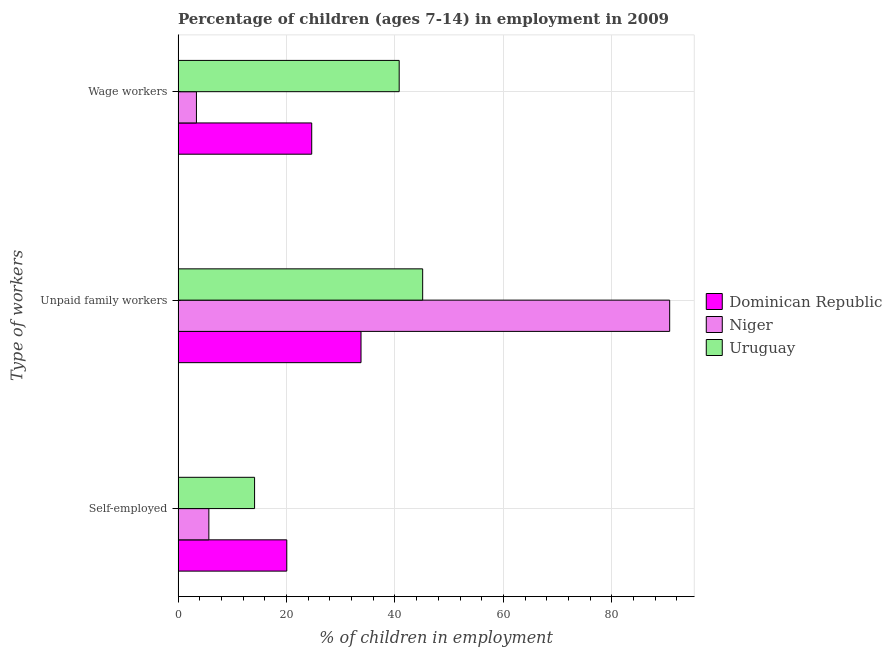How many different coloured bars are there?
Give a very brief answer. 3. How many groups of bars are there?
Provide a short and direct response. 3. What is the label of the 3rd group of bars from the top?
Provide a short and direct response. Self-employed. What is the percentage of self employed children in Niger?
Ensure brevity in your answer.  5.68. Across all countries, what is the maximum percentage of children employed as wage workers?
Ensure brevity in your answer.  40.78. Across all countries, what is the minimum percentage of children employed as unpaid family workers?
Ensure brevity in your answer.  33.74. In which country was the percentage of children employed as unpaid family workers maximum?
Your response must be concise. Niger. In which country was the percentage of children employed as unpaid family workers minimum?
Keep it short and to the point. Dominican Republic. What is the total percentage of children employed as wage workers in the graph?
Ensure brevity in your answer.  68.82. What is the difference between the percentage of self employed children in Dominican Republic and that in Niger?
Provide a succinct answer. 14.37. What is the difference between the percentage of children employed as unpaid family workers in Dominican Republic and the percentage of self employed children in Niger?
Ensure brevity in your answer.  28.06. What is the average percentage of children employed as unpaid family workers per country?
Offer a terse response. 56.5. What is the difference between the percentage of children employed as unpaid family workers and percentage of children employed as wage workers in Dominican Republic?
Your answer should be compact. 9.09. What is the ratio of the percentage of self employed children in Dominican Republic to that in Niger?
Offer a very short reply. 3.53. What is the difference between the highest and the second highest percentage of self employed children?
Provide a succinct answer. 5.94. What is the difference between the highest and the lowest percentage of children employed as wage workers?
Make the answer very short. 37.39. In how many countries, is the percentage of children employed as wage workers greater than the average percentage of children employed as wage workers taken over all countries?
Your response must be concise. 2. What does the 2nd bar from the top in Self-employed represents?
Offer a very short reply. Niger. What does the 1st bar from the bottom in Wage workers represents?
Give a very brief answer. Dominican Republic. Is it the case that in every country, the sum of the percentage of self employed children and percentage of children employed as unpaid family workers is greater than the percentage of children employed as wage workers?
Make the answer very short. Yes. Are all the bars in the graph horizontal?
Provide a succinct answer. Yes. How many countries are there in the graph?
Make the answer very short. 3. What is the difference between two consecutive major ticks on the X-axis?
Your response must be concise. 20. Are the values on the major ticks of X-axis written in scientific E-notation?
Offer a terse response. No. Does the graph contain any zero values?
Offer a terse response. No. How many legend labels are there?
Offer a terse response. 3. What is the title of the graph?
Your answer should be very brief. Percentage of children (ages 7-14) in employment in 2009. Does "Middle income" appear as one of the legend labels in the graph?
Offer a very short reply. No. What is the label or title of the X-axis?
Make the answer very short. % of children in employment. What is the label or title of the Y-axis?
Offer a very short reply. Type of workers. What is the % of children in employment of Dominican Republic in Self-employed?
Make the answer very short. 20.05. What is the % of children in employment in Niger in Self-employed?
Provide a short and direct response. 5.68. What is the % of children in employment of Uruguay in Self-employed?
Your answer should be very brief. 14.11. What is the % of children in employment of Dominican Republic in Unpaid family workers?
Ensure brevity in your answer.  33.74. What is the % of children in employment of Niger in Unpaid family workers?
Offer a terse response. 90.66. What is the % of children in employment of Uruguay in Unpaid family workers?
Provide a succinct answer. 45.11. What is the % of children in employment of Dominican Republic in Wage workers?
Offer a terse response. 24.65. What is the % of children in employment of Niger in Wage workers?
Provide a succinct answer. 3.39. What is the % of children in employment of Uruguay in Wage workers?
Offer a terse response. 40.78. Across all Type of workers, what is the maximum % of children in employment of Dominican Republic?
Make the answer very short. 33.74. Across all Type of workers, what is the maximum % of children in employment of Niger?
Provide a short and direct response. 90.66. Across all Type of workers, what is the maximum % of children in employment of Uruguay?
Offer a very short reply. 45.11. Across all Type of workers, what is the minimum % of children in employment in Dominican Republic?
Keep it short and to the point. 20.05. Across all Type of workers, what is the minimum % of children in employment of Niger?
Give a very brief answer. 3.39. Across all Type of workers, what is the minimum % of children in employment in Uruguay?
Offer a very short reply. 14.11. What is the total % of children in employment in Dominican Republic in the graph?
Your answer should be very brief. 78.44. What is the total % of children in employment in Niger in the graph?
Your answer should be very brief. 99.73. What is the difference between the % of children in employment of Dominican Republic in Self-employed and that in Unpaid family workers?
Provide a succinct answer. -13.69. What is the difference between the % of children in employment of Niger in Self-employed and that in Unpaid family workers?
Keep it short and to the point. -84.98. What is the difference between the % of children in employment in Uruguay in Self-employed and that in Unpaid family workers?
Provide a succinct answer. -31. What is the difference between the % of children in employment of Niger in Self-employed and that in Wage workers?
Offer a terse response. 2.29. What is the difference between the % of children in employment in Uruguay in Self-employed and that in Wage workers?
Keep it short and to the point. -26.67. What is the difference between the % of children in employment of Dominican Republic in Unpaid family workers and that in Wage workers?
Offer a very short reply. 9.09. What is the difference between the % of children in employment in Niger in Unpaid family workers and that in Wage workers?
Offer a very short reply. 87.27. What is the difference between the % of children in employment of Uruguay in Unpaid family workers and that in Wage workers?
Offer a very short reply. 4.33. What is the difference between the % of children in employment of Dominican Republic in Self-employed and the % of children in employment of Niger in Unpaid family workers?
Offer a terse response. -70.61. What is the difference between the % of children in employment in Dominican Republic in Self-employed and the % of children in employment in Uruguay in Unpaid family workers?
Ensure brevity in your answer.  -25.06. What is the difference between the % of children in employment of Niger in Self-employed and the % of children in employment of Uruguay in Unpaid family workers?
Keep it short and to the point. -39.43. What is the difference between the % of children in employment of Dominican Republic in Self-employed and the % of children in employment of Niger in Wage workers?
Provide a succinct answer. 16.66. What is the difference between the % of children in employment of Dominican Republic in Self-employed and the % of children in employment of Uruguay in Wage workers?
Offer a very short reply. -20.73. What is the difference between the % of children in employment of Niger in Self-employed and the % of children in employment of Uruguay in Wage workers?
Your response must be concise. -35.1. What is the difference between the % of children in employment in Dominican Republic in Unpaid family workers and the % of children in employment in Niger in Wage workers?
Keep it short and to the point. 30.35. What is the difference between the % of children in employment in Dominican Republic in Unpaid family workers and the % of children in employment in Uruguay in Wage workers?
Provide a succinct answer. -7.04. What is the difference between the % of children in employment in Niger in Unpaid family workers and the % of children in employment in Uruguay in Wage workers?
Your answer should be very brief. 49.88. What is the average % of children in employment in Dominican Republic per Type of workers?
Your response must be concise. 26.15. What is the average % of children in employment in Niger per Type of workers?
Make the answer very short. 33.24. What is the average % of children in employment in Uruguay per Type of workers?
Provide a succinct answer. 33.33. What is the difference between the % of children in employment of Dominican Republic and % of children in employment of Niger in Self-employed?
Offer a terse response. 14.37. What is the difference between the % of children in employment in Dominican Republic and % of children in employment in Uruguay in Self-employed?
Your answer should be compact. 5.94. What is the difference between the % of children in employment of Niger and % of children in employment of Uruguay in Self-employed?
Make the answer very short. -8.43. What is the difference between the % of children in employment of Dominican Republic and % of children in employment of Niger in Unpaid family workers?
Offer a very short reply. -56.92. What is the difference between the % of children in employment of Dominican Republic and % of children in employment of Uruguay in Unpaid family workers?
Offer a very short reply. -11.37. What is the difference between the % of children in employment in Niger and % of children in employment in Uruguay in Unpaid family workers?
Provide a short and direct response. 45.55. What is the difference between the % of children in employment in Dominican Republic and % of children in employment in Niger in Wage workers?
Give a very brief answer. 21.26. What is the difference between the % of children in employment in Dominican Republic and % of children in employment in Uruguay in Wage workers?
Keep it short and to the point. -16.13. What is the difference between the % of children in employment in Niger and % of children in employment in Uruguay in Wage workers?
Your answer should be very brief. -37.39. What is the ratio of the % of children in employment in Dominican Republic in Self-employed to that in Unpaid family workers?
Offer a terse response. 0.59. What is the ratio of the % of children in employment of Niger in Self-employed to that in Unpaid family workers?
Ensure brevity in your answer.  0.06. What is the ratio of the % of children in employment of Uruguay in Self-employed to that in Unpaid family workers?
Offer a terse response. 0.31. What is the ratio of the % of children in employment in Dominican Republic in Self-employed to that in Wage workers?
Offer a terse response. 0.81. What is the ratio of the % of children in employment of Niger in Self-employed to that in Wage workers?
Offer a terse response. 1.68. What is the ratio of the % of children in employment of Uruguay in Self-employed to that in Wage workers?
Your response must be concise. 0.35. What is the ratio of the % of children in employment in Dominican Republic in Unpaid family workers to that in Wage workers?
Offer a terse response. 1.37. What is the ratio of the % of children in employment of Niger in Unpaid family workers to that in Wage workers?
Your answer should be very brief. 26.74. What is the ratio of the % of children in employment in Uruguay in Unpaid family workers to that in Wage workers?
Your answer should be very brief. 1.11. What is the difference between the highest and the second highest % of children in employment in Dominican Republic?
Provide a short and direct response. 9.09. What is the difference between the highest and the second highest % of children in employment in Niger?
Provide a succinct answer. 84.98. What is the difference between the highest and the second highest % of children in employment in Uruguay?
Keep it short and to the point. 4.33. What is the difference between the highest and the lowest % of children in employment in Dominican Republic?
Your answer should be very brief. 13.69. What is the difference between the highest and the lowest % of children in employment of Niger?
Keep it short and to the point. 87.27. What is the difference between the highest and the lowest % of children in employment in Uruguay?
Give a very brief answer. 31. 